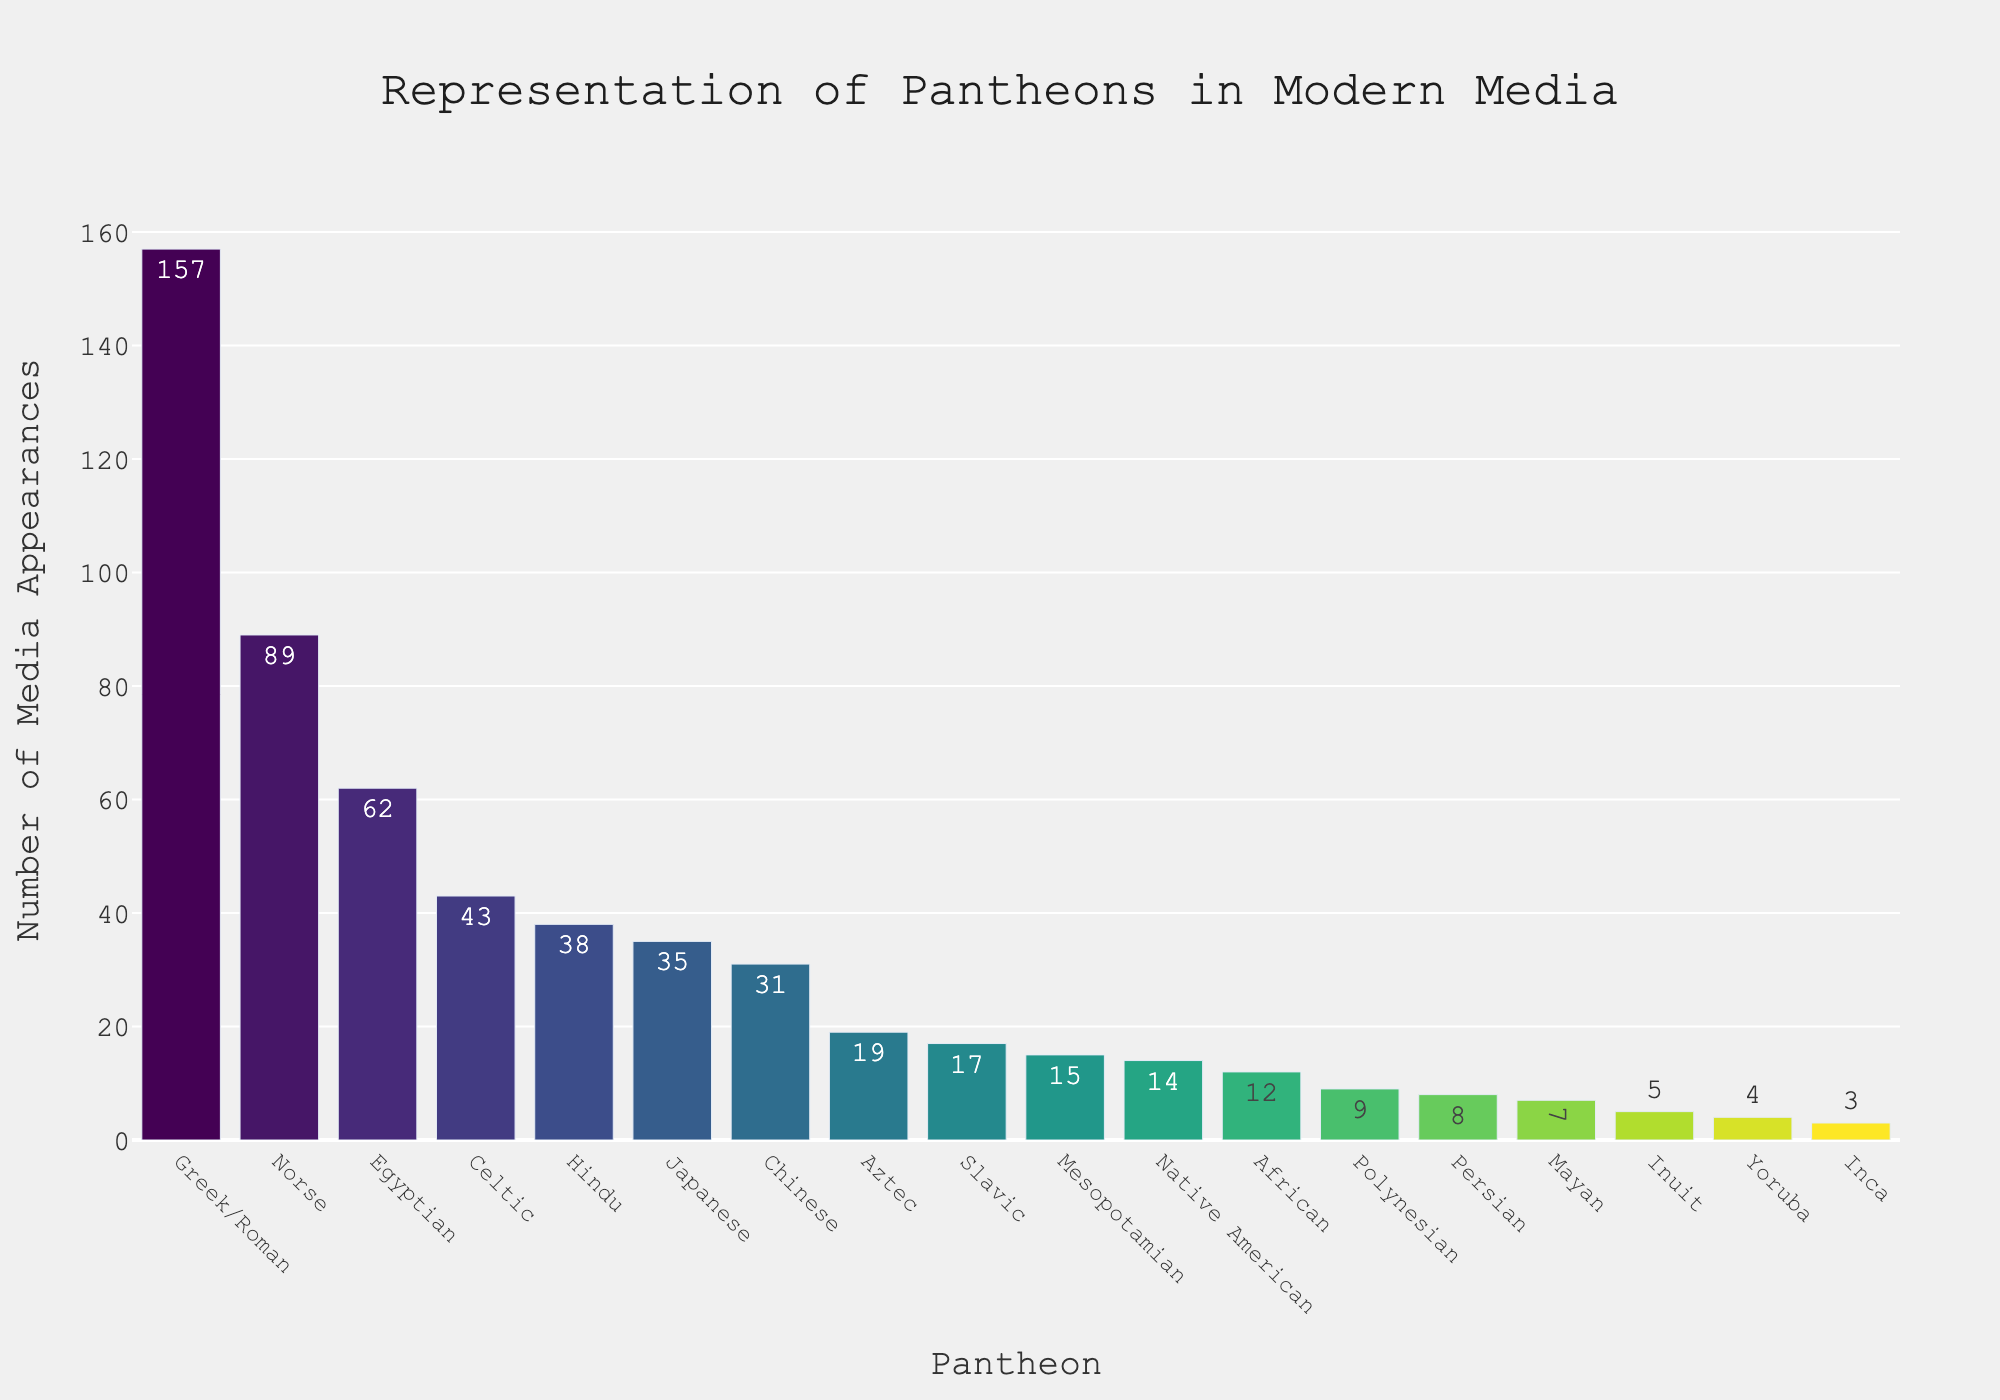Which pantheon has the highest number of media appearances? The Greek/Roman pantheon has the tallest bar, representing the highest number of media appearances.
Answer: Greek/Roman How many more media appearances does the Greek/Roman pantheon have compared to the Norse pantheon? The Greek/Roman pantheon has 157 appearances, and the Norse pantheon has 89 appearances. Subtracting these gives 157 - 89 = 68.
Answer: 68 What is the total number of media appearances for the Egyptian, Celtic, and Hindu pantheons combined? The Egyptian pantheon has 62 appearances, the Celtic pantheon has 43, and the Hindu pantheon has 38. Adding these gives 62 + 43 + 38 = 143.
Answer: 143 Which pantheons have fewer media appearances than the Egyptian pantheon but more than the Chinese pantheon? The Egyptian pantheon has 62 appearances, and the Chinese pantheon has 31. The Celtic pantheon with 43 appearances, the Hindu pantheon with 38 appearances, and the Japanese pantheon with 35 appearances fall in this range.
Answer: Celtic, Hindu, Japanese What’s the average number of media appearances for the bottom five pantheons? The bottom five pantheons are Yoruba (4), Inca (3), Persian (8), Inuit (5), and Mayan (7), which sum to 4 + 3 + 8 + 5 + 7 = 27. The average is 27 / 5 = 5.4.
Answer: 5.4 How does the number of media appearances of the Mesopotamian pantheon compare to the Native American pantheon? The Mesopotamian pantheon has 15 appearances, and the Native American pantheon has 14 appearances. The Mesopotamian pantheon has 1 more appearance than the Native American pantheon.
Answer: Mesopotamian has 1 more If the number of media appearances of the Chinese pantheon doubled, how would it compare to the Egyptian pantheon? Doubling the Chinese pantheon’s appearances (31) gives 31 * 2 = 62, which is the same as the Egyptian pantheon’s appearances (62).
Answer: Equal What percentage of total media appearances does the Greek/Roman pantheon represent (rounded to the nearest whole number)? The total number of media appearances is 157 + 89 + 62 + 43 + 38 + 35 + 31 + 19 + 17 + 15 + 14 + 12 + 9 + 8 + 7 + 5 + 4 + 3 = 568. The Greek/Roman pantheon has 157 appearances. The percentage is (157 / 568) * 100 ≈ 27.63%, rounded to 28%.
Answer: 28% Which pantheon has a bar that is approximately half the height of the Greek/Roman pantheon’s bar? The Greek/Roman pantheon has 157 appearances, and half of this is approximately 157 / 2 = 78.5. The Norse pantheon, with 89 appearances, is closest to this value.
Answer: Norse 